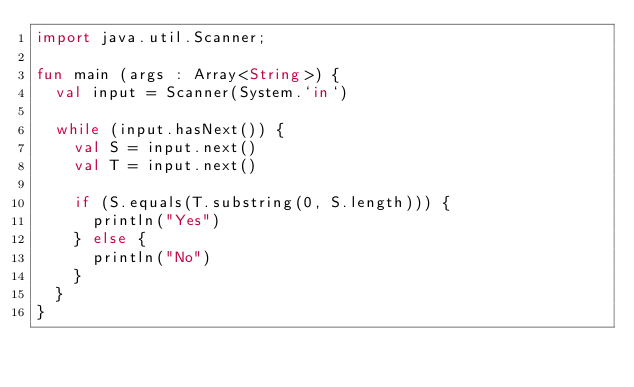Convert code to text. <code><loc_0><loc_0><loc_500><loc_500><_Kotlin_>import java.util.Scanner;

fun main (args : Array<String>) {
  val input = Scanner(System.`in`)
  
  while (input.hasNext()) {
    val S = input.next()
    val T = input.next()
    
    if (S.equals(T.substring(0, S.length))) {
      println("Yes")
    } else {
      println("No")
    }
  }
}</code> 